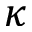<formula> <loc_0><loc_0><loc_500><loc_500>\kappa</formula> 